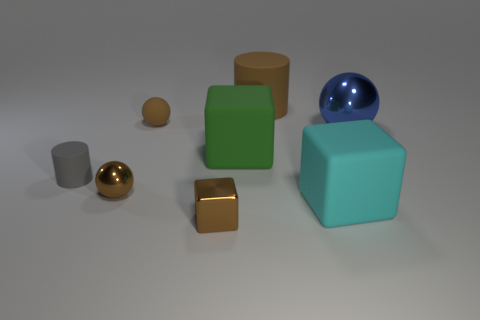There is a big thing that is the same color as the small metal cube; what shape is it?
Provide a succinct answer. Cylinder. What number of objects are both in front of the large brown rubber object and left of the big metal ball?
Make the answer very short. 6. How many objects are either brown metal spheres or tiny shiny things that are behind the big cyan thing?
Give a very brief answer. 1. Are there more large blue shiny spheres than yellow rubber balls?
Keep it short and to the point. Yes. What shape is the brown matte object that is on the left side of the large brown matte thing?
Make the answer very short. Sphere. What number of tiny things have the same shape as the big brown matte object?
Your response must be concise. 1. There is a cylinder behind the ball to the right of the tiny brown matte ball; what size is it?
Provide a short and direct response. Large. How many blue things are tiny rubber things or matte balls?
Offer a very short reply. 0. Are there fewer brown cubes that are behind the big sphere than rubber cylinders in front of the brown cylinder?
Give a very brief answer. Yes. There is a green matte object; is it the same size as the cylinder that is in front of the tiny brown rubber thing?
Ensure brevity in your answer.  No. 